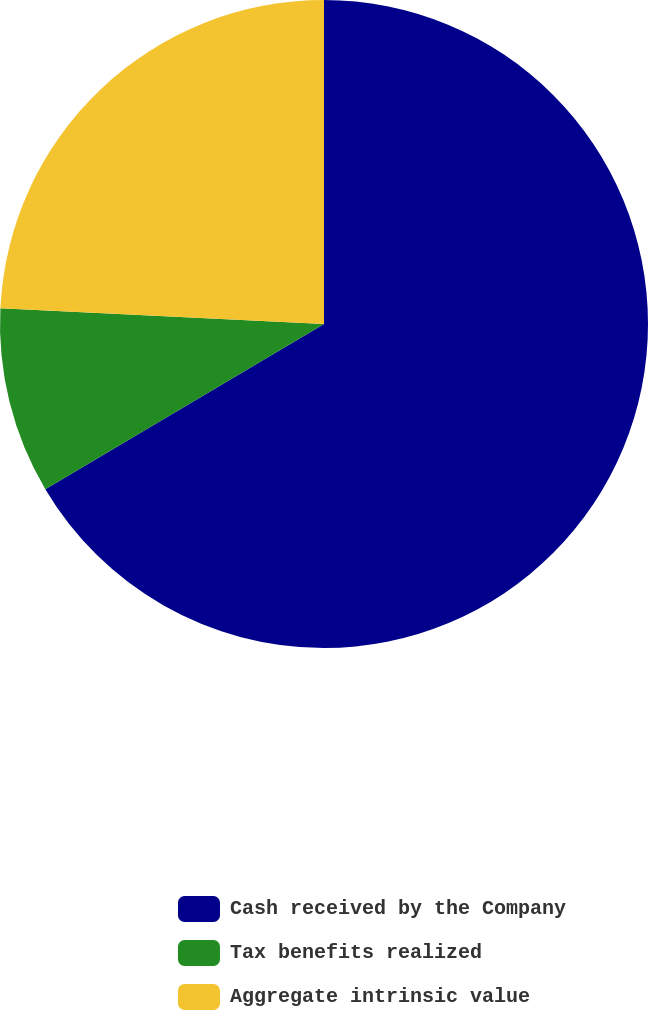Convert chart. <chart><loc_0><loc_0><loc_500><loc_500><pie_chart><fcel>Cash received by the Company<fcel>Tax benefits realized<fcel>Aggregate intrinsic value<nl><fcel>66.48%<fcel>9.29%<fcel>24.23%<nl></chart> 